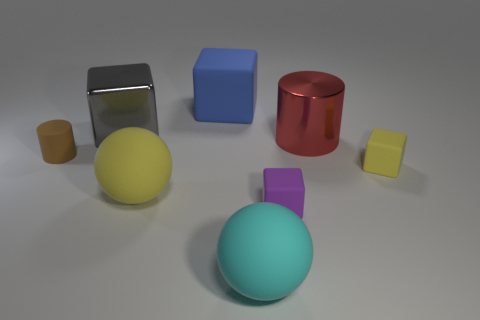What materials do the objects in the image appear to be made of? The objects in the image seem to have various materials. The sphere in the foreground has a smooth surface that suggests it could be made of plastic or painted metal. The shiny silver object looks like reflective metal, possibly stainless steel. The blue and red objects have matte finishes that could be plastic or metal with a painted coat, while the two smaller blocks appear to be wooden. 